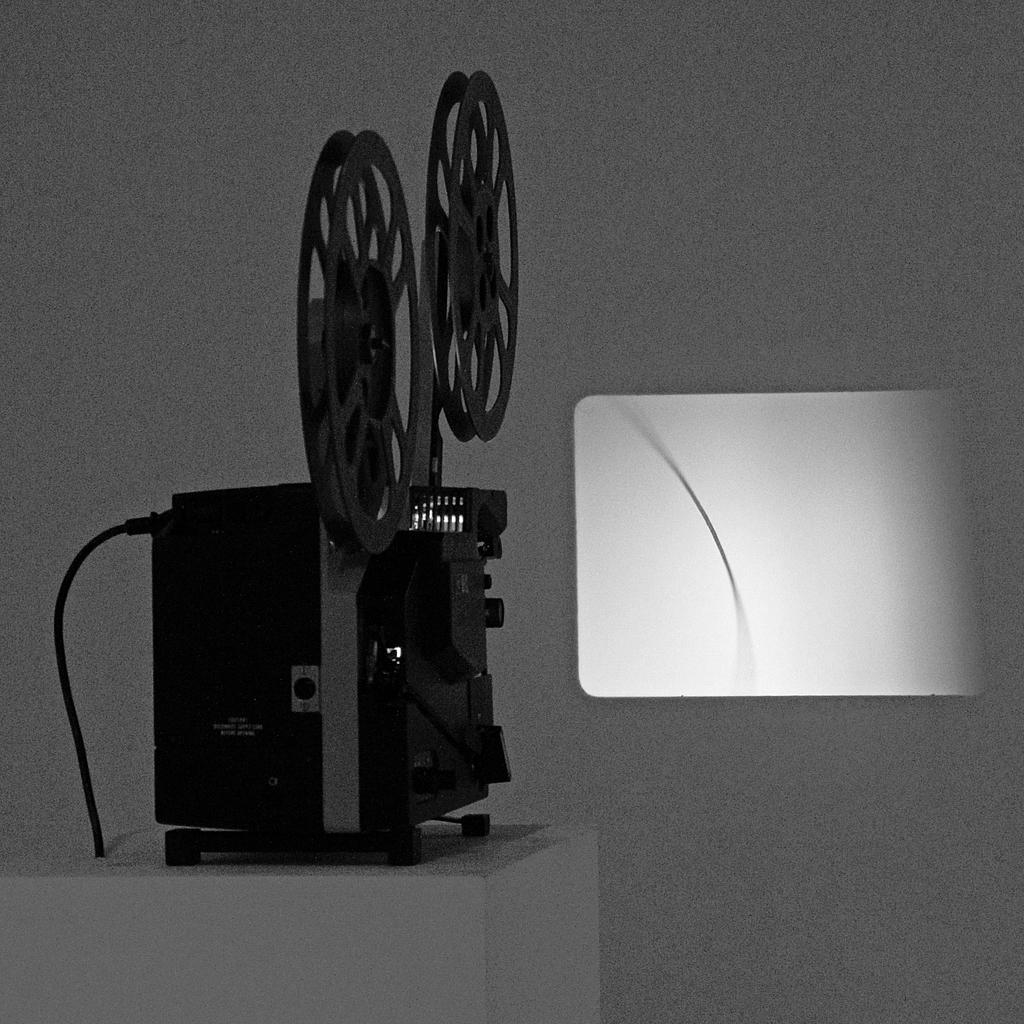What type of object is in the image? There is an electronic gadget in the image. Where is the electronic gadget located? The electronic gadget is on a table. What can be seen behind the gadget? There is a wall visible behind the gadget. What is happening on the wall? There is projected light on the wall. What type of wine is being served to the mother during the vacation in the image? There is no wine, mother, or vacation present in the image; it features an electronic gadget on a table with projected light on a wall. 